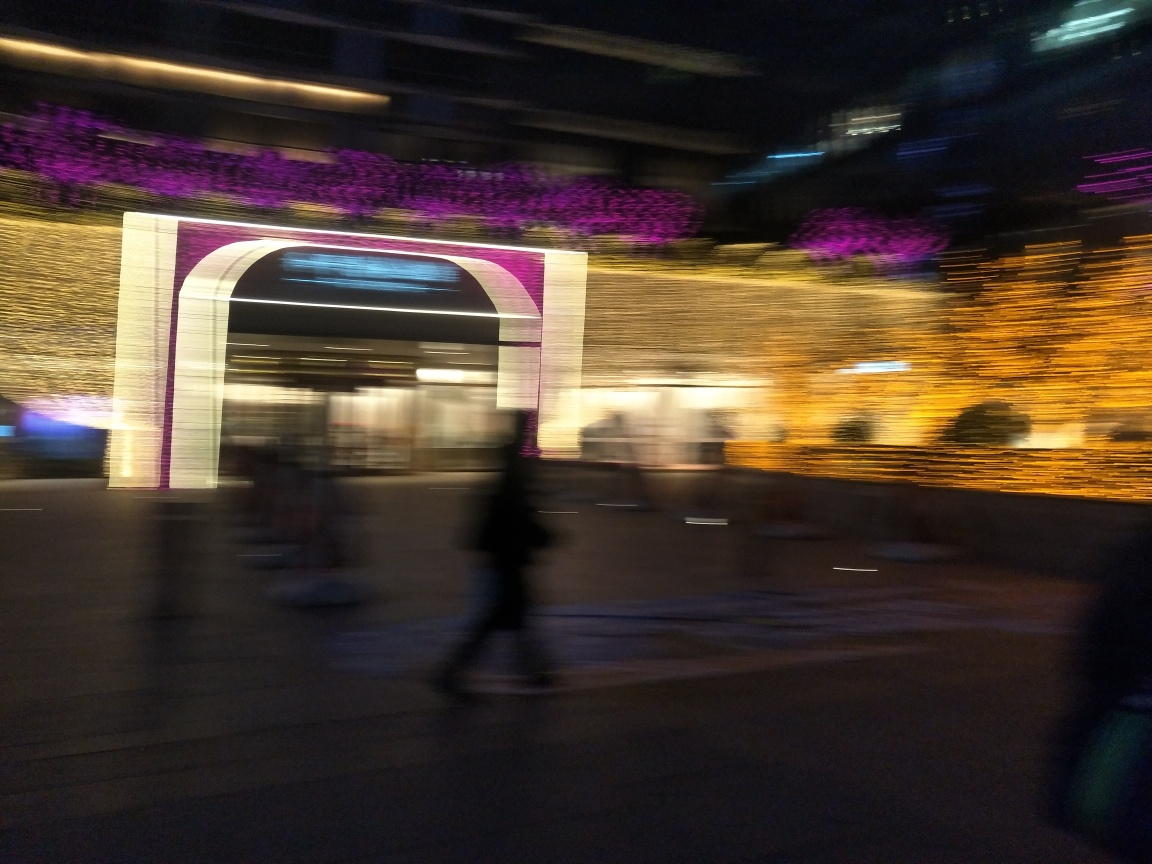What can you infer about the movement of people within the image? The blurred figures give the impression of people moving quickly or the camera moving during the shot, creating a sense of bustling activity or haste. 